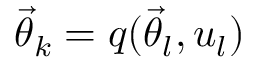Convert formula to latex. <formula><loc_0><loc_0><loc_500><loc_500>{ \vec { \theta } } _ { k } = q ( { \vec { \theta } } _ { l } , u _ { l } )</formula> 